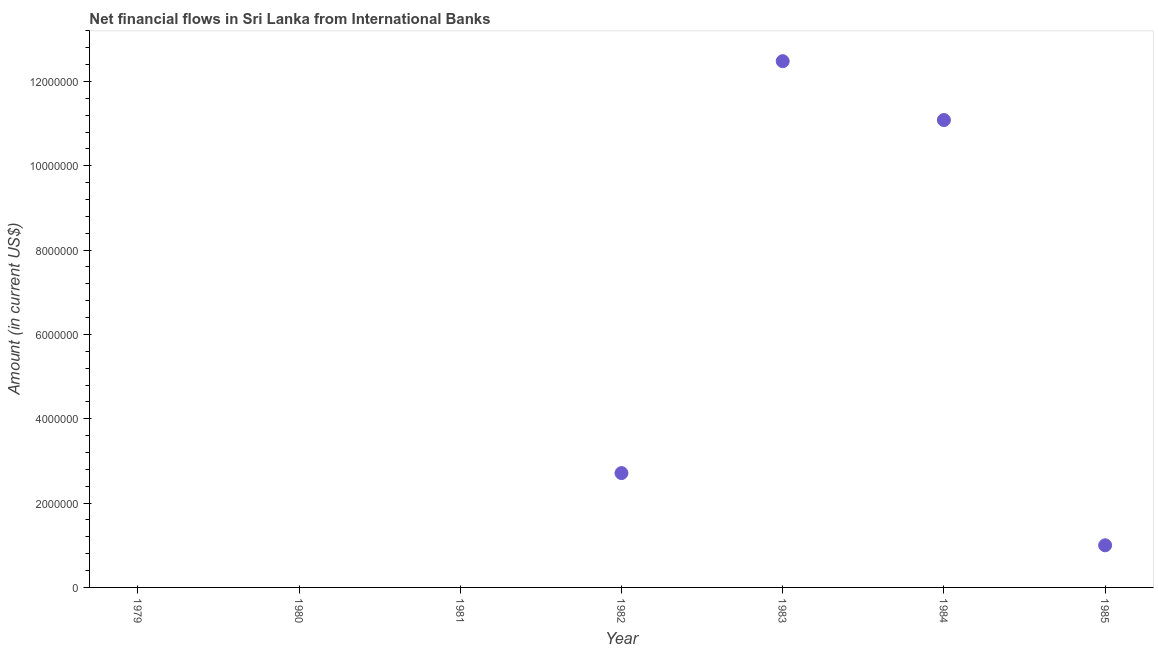What is the net financial flows from ibrd in 1980?
Provide a succinct answer. 0. Across all years, what is the maximum net financial flows from ibrd?
Provide a succinct answer. 1.25e+07. In which year was the net financial flows from ibrd maximum?
Provide a succinct answer. 1983. What is the sum of the net financial flows from ibrd?
Ensure brevity in your answer.  2.73e+07. What is the difference between the net financial flows from ibrd in 1983 and 1985?
Make the answer very short. 1.15e+07. What is the average net financial flows from ibrd per year?
Make the answer very short. 3.90e+06. What is the median net financial flows from ibrd?
Provide a succinct answer. 9.99e+05. What is the ratio of the net financial flows from ibrd in 1982 to that in 1983?
Ensure brevity in your answer.  0.22. Is the net financial flows from ibrd in 1982 less than that in 1983?
Offer a terse response. Yes. Is the difference between the net financial flows from ibrd in 1983 and 1984 greater than the difference between any two years?
Provide a succinct answer. No. What is the difference between the highest and the second highest net financial flows from ibrd?
Your response must be concise. 1.40e+06. Is the sum of the net financial flows from ibrd in 1982 and 1985 greater than the maximum net financial flows from ibrd across all years?
Your answer should be compact. No. What is the difference between the highest and the lowest net financial flows from ibrd?
Offer a terse response. 1.25e+07. How many dotlines are there?
Provide a short and direct response. 1. What is the difference between two consecutive major ticks on the Y-axis?
Provide a short and direct response. 2.00e+06. Does the graph contain any zero values?
Your answer should be very brief. Yes. What is the title of the graph?
Ensure brevity in your answer.  Net financial flows in Sri Lanka from International Banks. What is the Amount (in current US$) in 1979?
Provide a short and direct response. 0. What is the Amount (in current US$) in 1982?
Offer a very short reply. 2.71e+06. What is the Amount (in current US$) in 1983?
Make the answer very short. 1.25e+07. What is the Amount (in current US$) in 1984?
Provide a short and direct response. 1.11e+07. What is the Amount (in current US$) in 1985?
Ensure brevity in your answer.  9.99e+05. What is the difference between the Amount (in current US$) in 1982 and 1983?
Offer a very short reply. -9.77e+06. What is the difference between the Amount (in current US$) in 1982 and 1984?
Ensure brevity in your answer.  -8.37e+06. What is the difference between the Amount (in current US$) in 1982 and 1985?
Your answer should be compact. 1.71e+06. What is the difference between the Amount (in current US$) in 1983 and 1984?
Make the answer very short. 1.40e+06. What is the difference between the Amount (in current US$) in 1983 and 1985?
Offer a very short reply. 1.15e+07. What is the difference between the Amount (in current US$) in 1984 and 1985?
Ensure brevity in your answer.  1.01e+07. What is the ratio of the Amount (in current US$) in 1982 to that in 1983?
Ensure brevity in your answer.  0.22. What is the ratio of the Amount (in current US$) in 1982 to that in 1984?
Give a very brief answer. 0.24. What is the ratio of the Amount (in current US$) in 1982 to that in 1985?
Provide a succinct answer. 2.71. What is the ratio of the Amount (in current US$) in 1983 to that in 1984?
Provide a short and direct response. 1.13. What is the ratio of the Amount (in current US$) in 1983 to that in 1985?
Offer a terse response. 12.49. What is the ratio of the Amount (in current US$) in 1984 to that in 1985?
Your answer should be very brief. 11.1. 